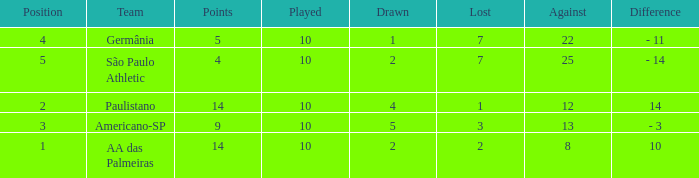What is the sum of Against when the lost is more than 7? None. Can you parse all the data within this table? {'header': ['Position', 'Team', 'Points', 'Played', 'Drawn', 'Lost', 'Against', 'Difference'], 'rows': [['4', 'Germânia', '5', '10', '1', '7', '22', '- 11'], ['5', 'São Paulo Athletic', '4', '10', '2', '7', '25', '- 14'], ['2', 'Paulistano', '14', '10', '4', '1', '12', '14'], ['3', 'Americano-SP', '9', '10', '5', '3', '13', '- 3'], ['1', 'AA das Palmeiras', '14', '10', '2', '2', '8', '10']]} 